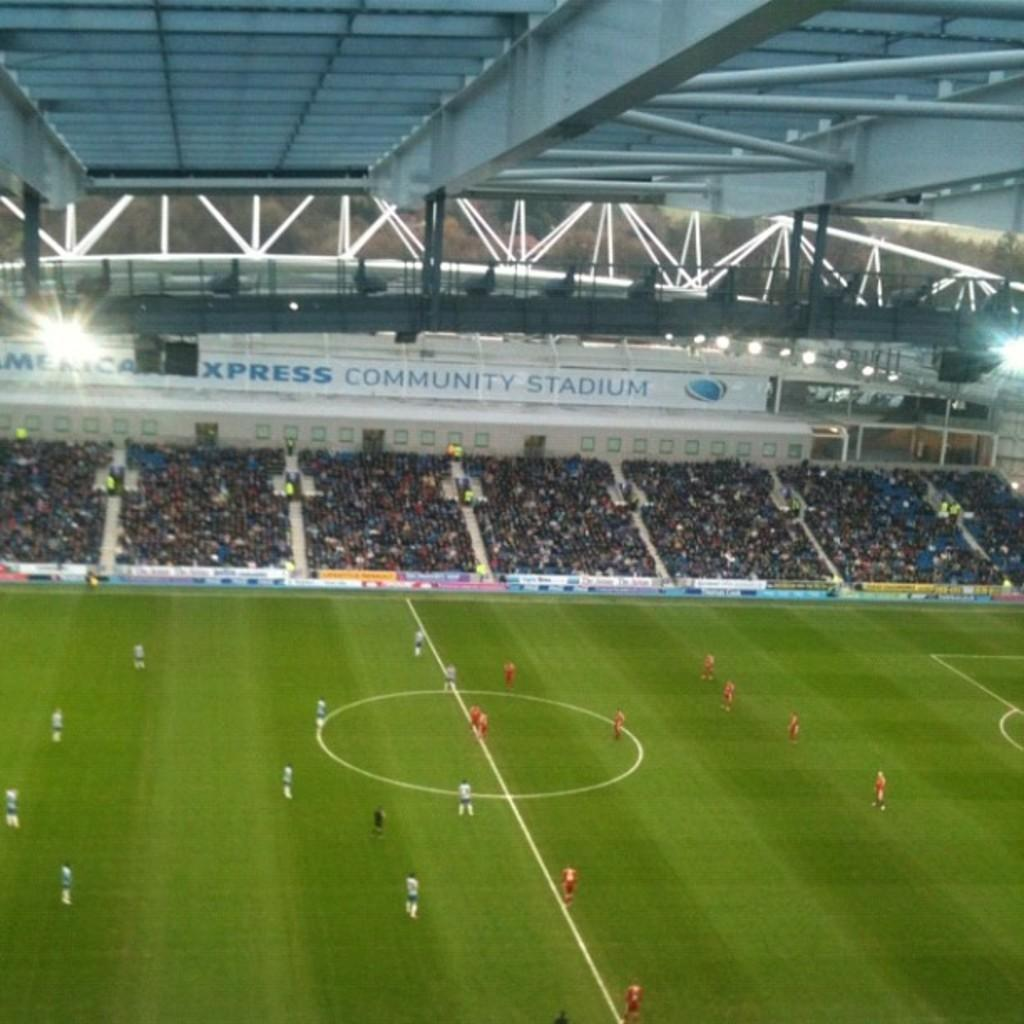<image>
Present a compact description of the photo's key features. A soccer match taking place in American Express Community Stadium 